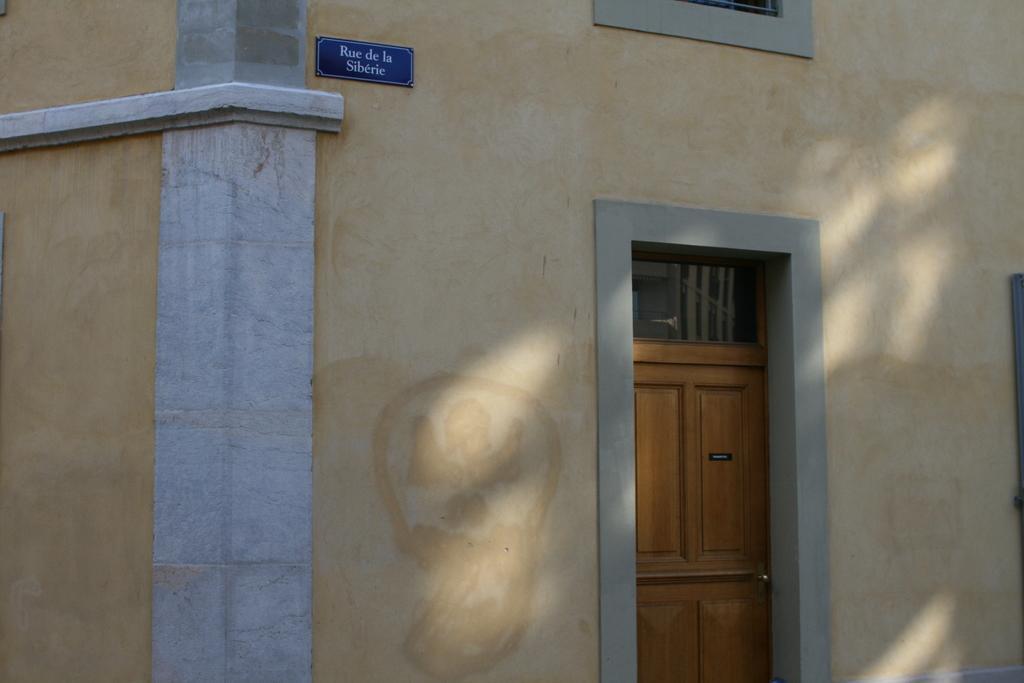Describe this image in one or two sentences. In this image in the center there is one building and there is one door, on the top of the image there is one board on the wall. 